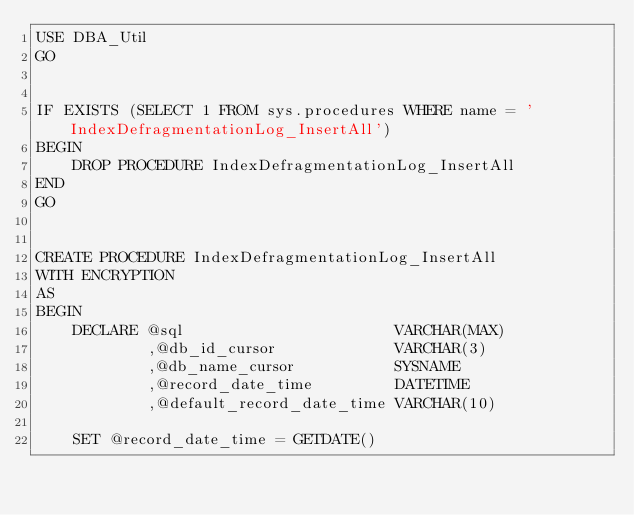Convert code to text. <code><loc_0><loc_0><loc_500><loc_500><_SQL_>USE DBA_Util
GO


IF EXISTS (SELECT 1 FROM sys.procedures WHERE name = 'IndexDefragmentationLog_InsertAll')
BEGIN
    DROP PROCEDURE IndexDefragmentationLog_InsertAll
END
GO


CREATE PROCEDURE IndexDefragmentationLog_InsertAll
WITH ENCRYPTION
AS
BEGIN
    DECLARE @sql                       VARCHAR(MAX)
            ,@db_id_cursor             VARCHAR(3)
            ,@db_name_cursor           SYSNAME
            ,@record_date_time         DATETIME
            ,@default_record_date_time VARCHAR(10)

    SET @record_date_time = GETDATE()</code> 